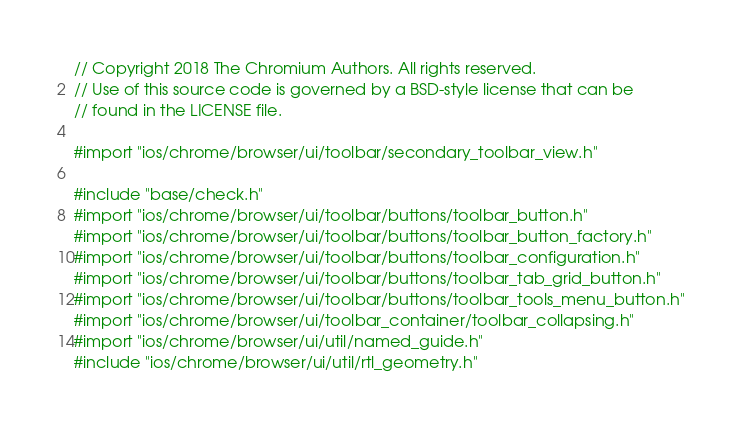<code> <loc_0><loc_0><loc_500><loc_500><_ObjectiveC_>// Copyright 2018 The Chromium Authors. All rights reserved.
// Use of this source code is governed by a BSD-style license that can be
// found in the LICENSE file.

#import "ios/chrome/browser/ui/toolbar/secondary_toolbar_view.h"

#include "base/check.h"
#import "ios/chrome/browser/ui/toolbar/buttons/toolbar_button.h"
#import "ios/chrome/browser/ui/toolbar/buttons/toolbar_button_factory.h"
#import "ios/chrome/browser/ui/toolbar/buttons/toolbar_configuration.h"
#import "ios/chrome/browser/ui/toolbar/buttons/toolbar_tab_grid_button.h"
#import "ios/chrome/browser/ui/toolbar/buttons/toolbar_tools_menu_button.h"
#import "ios/chrome/browser/ui/toolbar_container/toolbar_collapsing.h"
#import "ios/chrome/browser/ui/util/named_guide.h"
#include "ios/chrome/browser/ui/util/rtl_geometry.h"</code> 